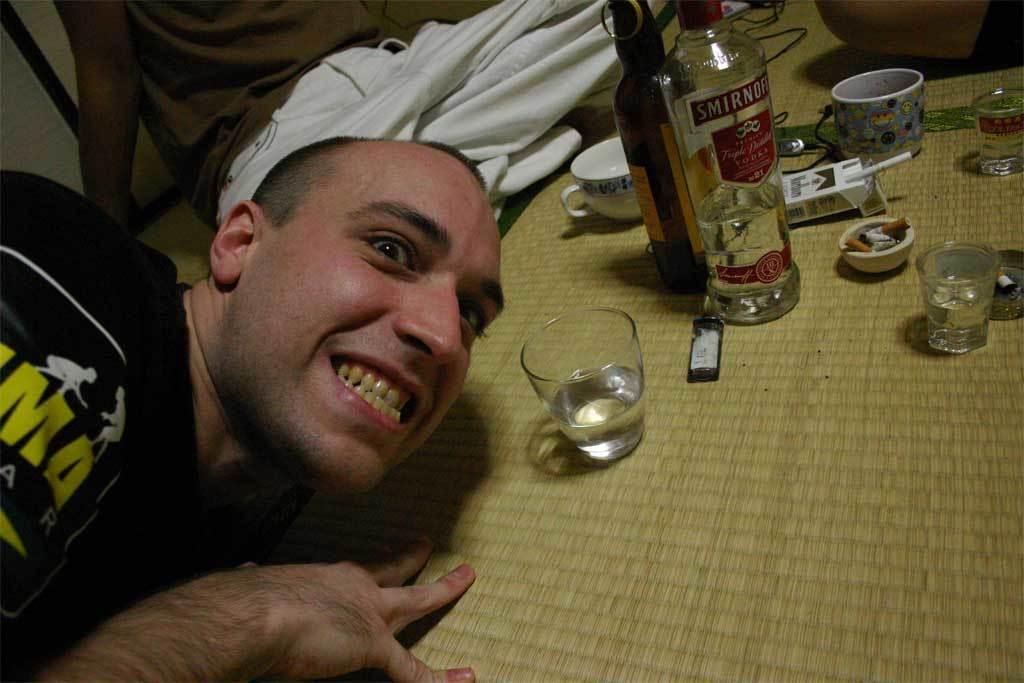Who is present in the image? There is a man in the image. What is the man's facial expression? The man is smiling. What types of containers are visible in the image? There are bottles, cups, and glasses in the image. How many legs does the man have in the image? The man has two legs, but this question is irrelevant to the image as it does not focus on the man's physical attributes. 